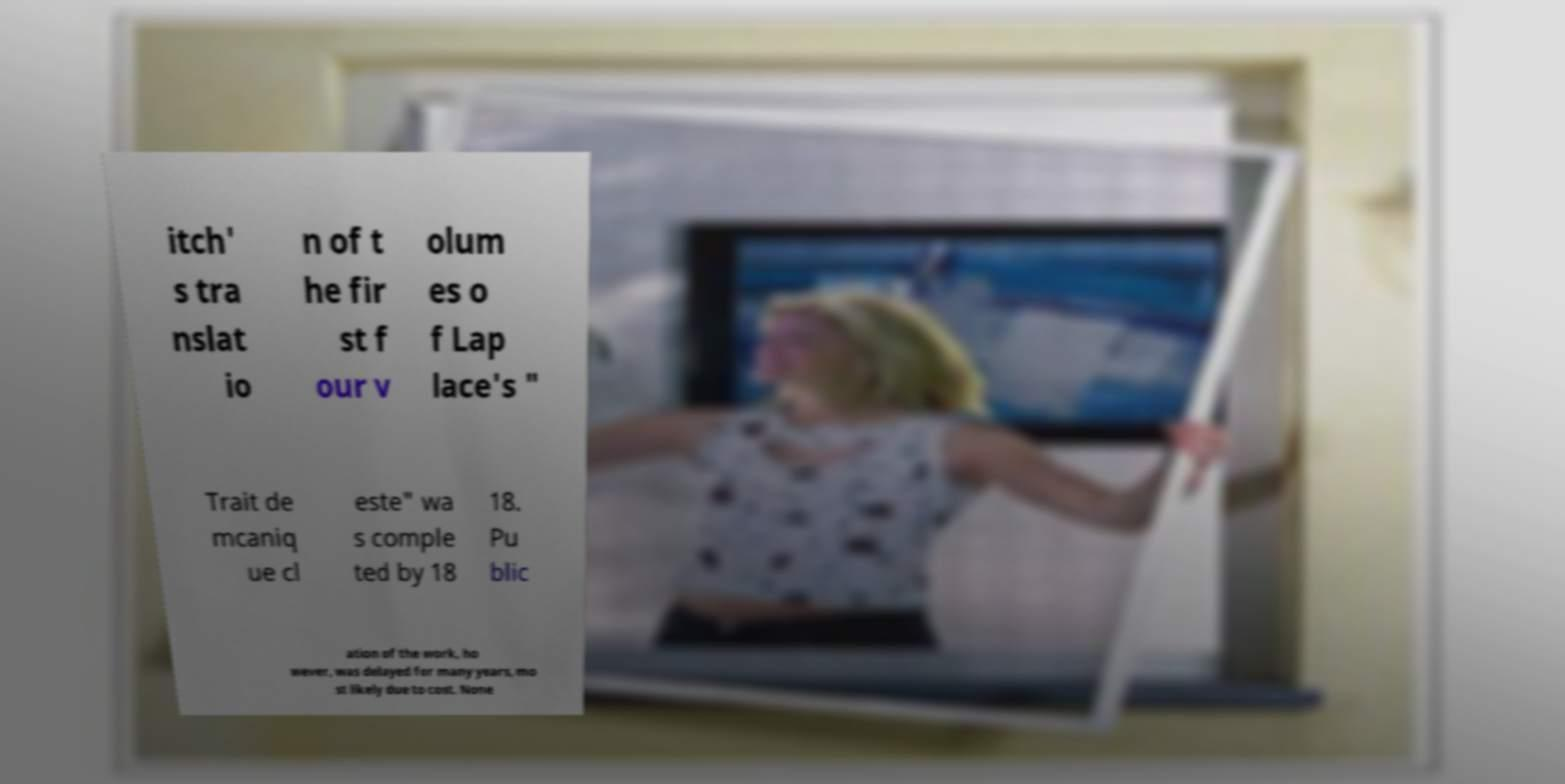For documentation purposes, I need the text within this image transcribed. Could you provide that? itch' s tra nslat io n of t he fir st f our v olum es o f Lap lace's " Trait de mcaniq ue cl este" wa s comple ted by 18 18. Pu blic ation of the work, ho wever, was delayed for many years, mo st likely due to cost. None 